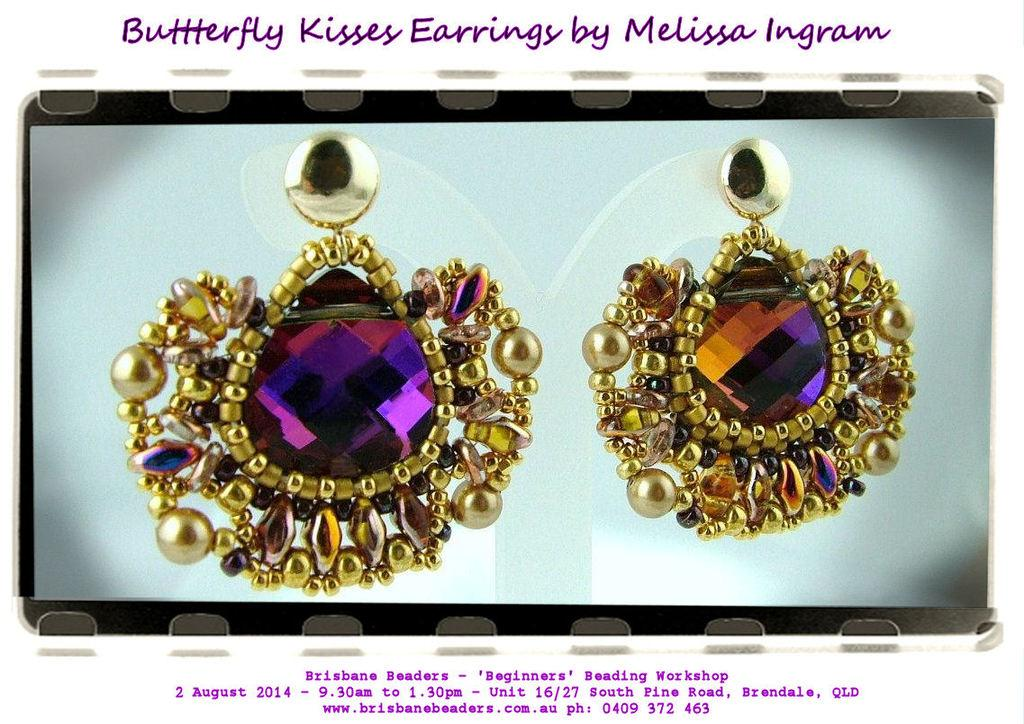<image>
Offer a succinct explanation of the picture presented. Large purple and gold earrings called the Butterfly Kisses sit on a gray background. 